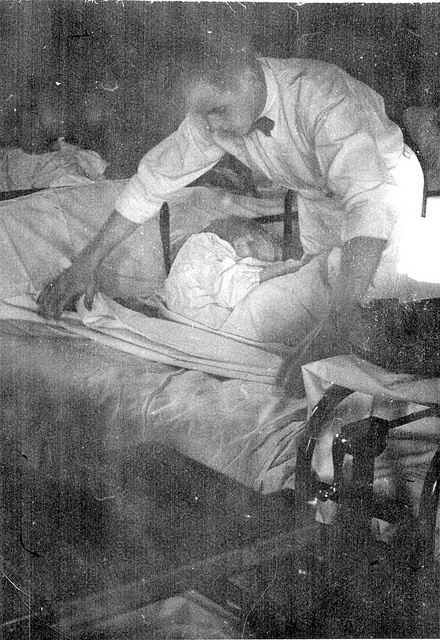Describe the objects in this image and their specific colors. I can see bed in gray, darkgray, lightgray, and black tones, people in gray, darkgray, lightgray, and black tones, people in gray, gainsboro, darkgray, and black tones, and tie in gray and lightgray tones in this image. 